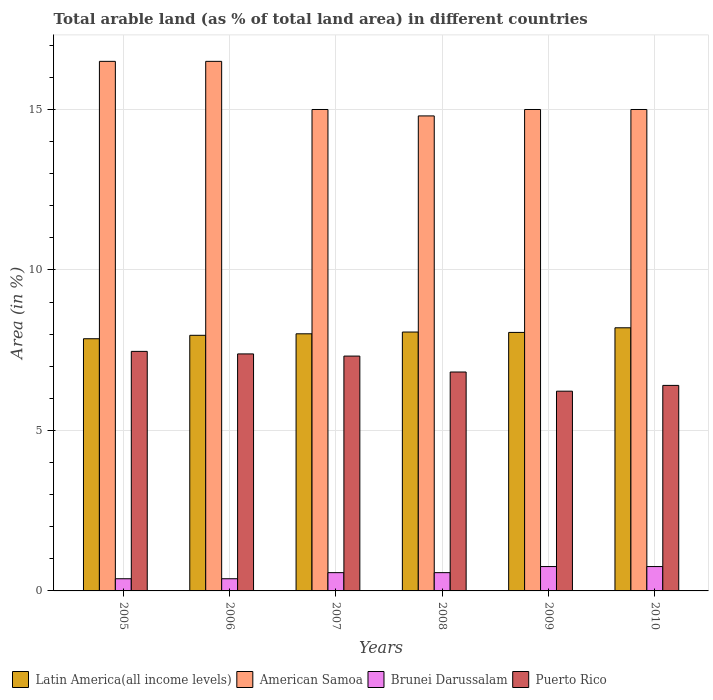How many different coloured bars are there?
Make the answer very short. 4. Are the number of bars on each tick of the X-axis equal?
Offer a terse response. Yes. What is the label of the 6th group of bars from the left?
Your response must be concise. 2010. What is the percentage of arable land in Puerto Rico in 2007?
Your answer should be very brief. 7.32. Across all years, what is the maximum percentage of arable land in Puerto Rico?
Ensure brevity in your answer.  7.46. Across all years, what is the minimum percentage of arable land in Brunei Darussalam?
Make the answer very short. 0.38. In which year was the percentage of arable land in Brunei Darussalam maximum?
Provide a short and direct response. 2009. In which year was the percentage of arable land in Puerto Rico minimum?
Give a very brief answer. 2009. What is the total percentage of arable land in Latin America(all income levels) in the graph?
Offer a very short reply. 48.15. What is the difference between the percentage of arable land in Puerto Rico in 2008 and that in 2010?
Your answer should be compact. 0.42. What is the difference between the percentage of arable land in Puerto Rico in 2010 and the percentage of arable land in Latin America(all income levels) in 2005?
Provide a short and direct response. -1.45. What is the average percentage of arable land in American Samoa per year?
Your answer should be compact. 15.47. In the year 2008, what is the difference between the percentage of arable land in Puerto Rico and percentage of arable land in Brunei Darussalam?
Your response must be concise. 6.25. What is the ratio of the percentage of arable land in Puerto Rico in 2005 to that in 2008?
Offer a terse response. 1.09. Is the difference between the percentage of arable land in Puerto Rico in 2007 and 2010 greater than the difference between the percentage of arable land in Brunei Darussalam in 2007 and 2010?
Provide a short and direct response. Yes. What is the difference between the highest and the second highest percentage of arable land in Latin America(all income levels)?
Your answer should be compact. 0.13. What is the difference between the highest and the lowest percentage of arable land in Latin America(all income levels)?
Keep it short and to the point. 0.34. In how many years, is the percentage of arable land in Brunei Darussalam greater than the average percentage of arable land in Brunei Darussalam taken over all years?
Your response must be concise. 2. Is the sum of the percentage of arable land in Puerto Rico in 2007 and 2008 greater than the maximum percentage of arable land in American Samoa across all years?
Provide a succinct answer. No. Is it the case that in every year, the sum of the percentage of arable land in Puerto Rico and percentage of arable land in American Samoa is greater than the sum of percentage of arable land in Latin America(all income levels) and percentage of arable land in Brunei Darussalam?
Ensure brevity in your answer.  Yes. What does the 4th bar from the left in 2010 represents?
Give a very brief answer. Puerto Rico. What does the 2nd bar from the right in 2009 represents?
Give a very brief answer. Brunei Darussalam. Are all the bars in the graph horizontal?
Provide a short and direct response. No. How many years are there in the graph?
Provide a succinct answer. 6. What is the difference between two consecutive major ticks on the Y-axis?
Your answer should be very brief. 5. Where does the legend appear in the graph?
Your response must be concise. Bottom left. What is the title of the graph?
Your response must be concise. Total arable land (as % of total land area) in different countries. What is the label or title of the Y-axis?
Ensure brevity in your answer.  Area (in %). What is the Area (in %) of Latin America(all income levels) in 2005?
Offer a very short reply. 7.86. What is the Area (in %) in Brunei Darussalam in 2005?
Make the answer very short. 0.38. What is the Area (in %) in Puerto Rico in 2005?
Ensure brevity in your answer.  7.46. What is the Area (in %) in Latin America(all income levels) in 2006?
Provide a succinct answer. 7.96. What is the Area (in %) of American Samoa in 2006?
Your answer should be very brief. 16.5. What is the Area (in %) in Brunei Darussalam in 2006?
Your answer should be compact. 0.38. What is the Area (in %) in Puerto Rico in 2006?
Give a very brief answer. 7.38. What is the Area (in %) of Latin America(all income levels) in 2007?
Make the answer very short. 8.01. What is the Area (in %) in American Samoa in 2007?
Provide a short and direct response. 15. What is the Area (in %) in Brunei Darussalam in 2007?
Your response must be concise. 0.57. What is the Area (in %) of Puerto Rico in 2007?
Your answer should be very brief. 7.32. What is the Area (in %) of Latin America(all income levels) in 2008?
Keep it short and to the point. 8.07. What is the Area (in %) in American Samoa in 2008?
Ensure brevity in your answer.  14.8. What is the Area (in %) in Brunei Darussalam in 2008?
Your response must be concise. 0.57. What is the Area (in %) of Puerto Rico in 2008?
Provide a short and direct response. 6.82. What is the Area (in %) in Latin America(all income levels) in 2009?
Your response must be concise. 8.05. What is the Area (in %) of American Samoa in 2009?
Your answer should be very brief. 15. What is the Area (in %) of Brunei Darussalam in 2009?
Make the answer very short. 0.76. What is the Area (in %) in Puerto Rico in 2009?
Provide a short and direct response. 6.22. What is the Area (in %) of Latin America(all income levels) in 2010?
Give a very brief answer. 8.2. What is the Area (in %) in Brunei Darussalam in 2010?
Your answer should be compact. 0.76. What is the Area (in %) in Puerto Rico in 2010?
Keep it short and to the point. 6.4. Across all years, what is the maximum Area (in %) of Latin America(all income levels)?
Offer a terse response. 8.2. Across all years, what is the maximum Area (in %) of Brunei Darussalam?
Provide a short and direct response. 0.76. Across all years, what is the maximum Area (in %) of Puerto Rico?
Provide a succinct answer. 7.46. Across all years, what is the minimum Area (in %) in Latin America(all income levels)?
Provide a short and direct response. 7.86. Across all years, what is the minimum Area (in %) of Brunei Darussalam?
Keep it short and to the point. 0.38. Across all years, what is the minimum Area (in %) of Puerto Rico?
Make the answer very short. 6.22. What is the total Area (in %) in Latin America(all income levels) in the graph?
Offer a very short reply. 48.15. What is the total Area (in %) of American Samoa in the graph?
Your answer should be very brief. 92.8. What is the total Area (in %) of Brunei Darussalam in the graph?
Provide a succinct answer. 3.42. What is the total Area (in %) of Puerto Rico in the graph?
Make the answer very short. 41.61. What is the difference between the Area (in %) in Latin America(all income levels) in 2005 and that in 2006?
Ensure brevity in your answer.  -0.11. What is the difference between the Area (in %) in Puerto Rico in 2005 and that in 2006?
Keep it short and to the point. 0.08. What is the difference between the Area (in %) of Latin America(all income levels) in 2005 and that in 2007?
Your response must be concise. -0.15. What is the difference between the Area (in %) in American Samoa in 2005 and that in 2007?
Provide a succinct answer. 1.5. What is the difference between the Area (in %) of Brunei Darussalam in 2005 and that in 2007?
Your answer should be compact. -0.19. What is the difference between the Area (in %) in Puerto Rico in 2005 and that in 2007?
Your answer should be very brief. 0.15. What is the difference between the Area (in %) of Latin America(all income levels) in 2005 and that in 2008?
Your answer should be very brief. -0.21. What is the difference between the Area (in %) of Brunei Darussalam in 2005 and that in 2008?
Offer a very short reply. -0.19. What is the difference between the Area (in %) of Puerto Rico in 2005 and that in 2008?
Your answer should be compact. 0.64. What is the difference between the Area (in %) of Latin America(all income levels) in 2005 and that in 2009?
Give a very brief answer. -0.2. What is the difference between the Area (in %) in Brunei Darussalam in 2005 and that in 2009?
Provide a succinct answer. -0.38. What is the difference between the Area (in %) in Puerto Rico in 2005 and that in 2009?
Offer a terse response. 1.24. What is the difference between the Area (in %) of Latin America(all income levels) in 2005 and that in 2010?
Provide a short and direct response. -0.34. What is the difference between the Area (in %) in American Samoa in 2005 and that in 2010?
Your answer should be compact. 1.5. What is the difference between the Area (in %) in Brunei Darussalam in 2005 and that in 2010?
Your answer should be very brief. -0.38. What is the difference between the Area (in %) in Puerto Rico in 2005 and that in 2010?
Keep it short and to the point. 1.06. What is the difference between the Area (in %) in Latin America(all income levels) in 2006 and that in 2007?
Your answer should be compact. -0.05. What is the difference between the Area (in %) of Brunei Darussalam in 2006 and that in 2007?
Make the answer very short. -0.19. What is the difference between the Area (in %) of Puerto Rico in 2006 and that in 2007?
Ensure brevity in your answer.  0.07. What is the difference between the Area (in %) of Latin America(all income levels) in 2006 and that in 2008?
Keep it short and to the point. -0.1. What is the difference between the Area (in %) in American Samoa in 2006 and that in 2008?
Provide a succinct answer. 1.7. What is the difference between the Area (in %) of Brunei Darussalam in 2006 and that in 2008?
Your answer should be compact. -0.19. What is the difference between the Area (in %) of Puerto Rico in 2006 and that in 2008?
Make the answer very short. 0.56. What is the difference between the Area (in %) of Latin America(all income levels) in 2006 and that in 2009?
Offer a very short reply. -0.09. What is the difference between the Area (in %) in American Samoa in 2006 and that in 2009?
Ensure brevity in your answer.  1.5. What is the difference between the Area (in %) of Brunei Darussalam in 2006 and that in 2009?
Your response must be concise. -0.38. What is the difference between the Area (in %) in Puerto Rico in 2006 and that in 2009?
Your answer should be compact. 1.16. What is the difference between the Area (in %) of Latin America(all income levels) in 2006 and that in 2010?
Your answer should be compact. -0.23. What is the difference between the Area (in %) of Brunei Darussalam in 2006 and that in 2010?
Provide a succinct answer. -0.38. What is the difference between the Area (in %) in Puerto Rico in 2006 and that in 2010?
Provide a succinct answer. 0.98. What is the difference between the Area (in %) in Latin America(all income levels) in 2007 and that in 2008?
Provide a succinct answer. -0.05. What is the difference between the Area (in %) of Puerto Rico in 2007 and that in 2008?
Give a very brief answer. 0.5. What is the difference between the Area (in %) in Latin America(all income levels) in 2007 and that in 2009?
Offer a terse response. -0.04. What is the difference between the Area (in %) in Brunei Darussalam in 2007 and that in 2009?
Keep it short and to the point. -0.19. What is the difference between the Area (in %) of Puerto Rico in 2007 and that in 2009?
Keep it short and to the point. 1.09. What is the difference between the Area (in %) in Latin America(all income levels) in 2007 and that in 2010?
Make the answer very short. -0.19. What is the difference between the Area (in %) of Brunei Darussalam in 2007 and that in 2010?
Your response must be concise. -0.19. What is the difference between the Area (in %) of Puerto Rico in 2007 and that in 2010?
Make the answer very short. 0.91. What is the difference between the Area (in %) in Latin America(all income levels) in 2008 and that in 2009?
Give a very brief answer. 0.01. What is the difference between the Area (in %) in American Samoa in 2008 and that in 2009?
Provide a short and direct response. -0.2. What is the difference between the Area (in %) of Brunei Darussalam in 2008 and that in 2009?
Provide a short and direct response. -0.19. What is the difference between the Area (in %) in Puerto Rico in 2008 and that in 2009?
Your answer should be compact. 0.6. What is the difference between the Area (in %) of Latin America(all income levels) in 2008 and that in 2010?
Provide a succinct answer. -0.13. What is the difference between the Area (in %) in American Samoa in 2008 and that in 2010?
Make the answer very short. -0.2. What is the difference between the Area (in %) of Brunei Darussalam in 2008 and that in 2010?
Your response must be concise. -0.19. What is the difference between the Area (in %) in Puerto Rico in 2008 and that in 2010?
Make the answer very short. 0.42. What is the difference between the Area (in %) in Latin America(all income levels) in 2009 and that in 2010?
Your answer should be very brief. -0.14. What is the difference between the Area (in %) of American Samoa in 2009 and that in 2010?
Give a very brief answer. 0. What is the difference between the Area (in %) of Brunei Darussalam in 2009 and that in 2010?
Your answer should be compact. 0. What is the difference between the Area (in %) of Puerto Rico in 2009 and that in 2010?
Provide a short and direct response. -0.18. What is the difference between the Area (in %) in Latin America(all income levels) in 2005 and the Area (in %) in American Samoa in 2006?
Ensure brevity in your answer.  -8.64. What is the difference between the Area (in %) in Latin America(all income levels) in 2005 and the Area (in %) in Brunei Darussalam in 2006?
Offer a terse response. 7.48. What is the difference between the Area (in %) of Latin America(all income levels) in 2005 and the Area (in %) of Puerto Rico in 2006?
Keep it short and to the point. 0.47. What is the difference between the Area (in %) in American Samoa in 2005 and the Area (in %) in Brunei Darussalam in 2006?
Make the answer very short. 16.12. What is the difference between the Area (in %) of American Samoa in 2005 and the Area (in %) of Puerto Rico in 2006?
Provide a succinct answer. 9.12. What is the difference between the Area (in %) in Brunei Darussalam in 2005 and the Area (in %) in Puerto Rico in 2006?
Keep it short and to the point. -7. What is the difference between the Area (in %) of Latin America(all income levels) in 2005 and the Area (in %) of American Samoa in 2007?
Keep it short and to the point. -7.14. What is the difference between the Area (in %) of Latin America(all income levels) in 2005 and the Area (in %) of Brunei Darussalam in 2007?
Give a very brief answer. 7.29. What is the difference between the Area (in %) in Latin America(all income levels) in 2005 and the Area (in %) in Puerto Rico in 2007?
Your response must be concise. 0.54. What is the difference between the Area (in %) in American Samoa in 2005 and the Area (in %) in Brunei Darussalam in 2007?
Make the answer very short. 15.93. What is the difference between the Area (in %) of American Samoa in 2005 and the Area (in %) of Puerto Rico in 2007?
Your answer should be compact. 9.18. What is the difference between the Area (in %) in Brunei Darussalam in 2005 and the Area (in %) in Puerto Rico in 2007?
Offer a very short reply. -6.94. What is the difference between the Area (in %) in Latin America(all income levels) in 2005 and the Area (in %) in American Samoa in 2008?
Offer a terse response. -6.94. What is the difference between the Area (in %) in Latin America(all income levels) in 2005 and the Area (in %) in Brunei Darussalam in 2008?
Provide a short and direct response. 7.29. What is the difference between the Area (in %) of Latin America(all income levels) in 2005 and the Area (in %) of Puerto Rico in 2008?
Provide a succinct answer. 1.04. What is the difference between the Area (in %) of American Samoa in 2005 and the Area (in %) of Brunei Darussalam in 2008?
Keep it short and to the point. 15.93. What is the difference between the Area (in %) of American Samoa in 2005 and the Area (in %) of Puerto Rico in 2008?
Give a very brief answer. 9.68. What is the difference between the Area (in %) in Brunei Darussalam in 2005 and the Area (in %) in Puerto Rico in 2008?
Your answer should be compact. -6.44. What is the difference between the Area (in %) in Latin America(all income levels) in 2005 and the Area (in %) in American Samoa in 2009?
Your answer should be very brief. -7.14. What is the difference between the Area (in %) of Latin America(all income levels) in 2005 and the Area (in %) of Brunei Darussalam in 2009?
Your answer should be compact. 7.1. What is the difference between the Area (in %) in Latin America(all income levels) in 2005 and the Area (in %) in Puerto Rico in 2009?
Give a very brief answer. 1.63. What is the difference between the Area (in %) in American Samoa in 2005 and the Area (in %) in Brunei Darussalam in 2009?
Your response must be concise. 15.74. What is the difference between the Area (in %) in American Samoa in 2005 and the Area (in %) in Puerto Rico in 2009?
Offer a terse response. 10.28. What is the difference between the Area (in %) of Brunei Darussalam in 2005 and the Area (in %) of Puerto Rico in 2009?
Keep it short and to the point. -5.84. What is the difference between the Area (in %) of Latin America(all income levels) in 2005 and the Area (in %) of American Samoa in 2010?
Provide a succinct answer. -7.14. What is the difference between the Area (in %) of Latin America(all income levels) in 2005 and the Area (in %) of Brunei Darussalam in 2010?
Ensure brevity in your answer.  7.1. What is the difference between the Area (in %) in Latin America(all income levels) in 2005 and the Area (in %) in Puerto Rico in 2010?
Offer a very short reply. 1.45. What is the difference between the Area (in %) of American Samoa in 2005 and the Area (in %) of Brunei Darussalam in 2010?
Your response must be concise. 15.74. What is the difference between the Area (in %) in American Samoa in 2005 and the Area (in %) in Puerto Rico in 2010?
Offer a terse response. 10.1. What is the difference between the Area (in %) of Brunei Darussalam in 2005 and the Area (in %) of Puerto Rico in 2010?
Provide a succinct answer. -6.02. What is the difference between the Area (in %) in Latin America(all income levels) in 2006 and the Area (in %) in American Samoa in 2007?
Your response must be concise. -7.04. What is the difference between the Area (in %) in Latin America(all income levels) in 2006 and the Area (in %) in Brunei Darussalam in 2007?
Keep it short and to the point. 7.39. What is the difference between the Area (in %) of Latin America(all income levels) in 2006 and the Area (in %) of Puerto Rico in 2007?
Give a very brief answer. 0.65. What is the difference between the Area (in %) of American Samoa in 2006 and the Area (in %) of Brunei Darussalam in 2007?
Provide a short and direct response. 15.93. What is the difference between the Area (in %) of American Samoa in 2006 and the Area (in %) of Puerto Rico in 2007?
Your answer should be compact. 9.18. What is the difference between the Area (in %) of Brunei Darussalam in 2006 and the Area (in %) of Puerto Rico in 2007?
Keep it short and to the point. -6.94. What is the difference between the Area (in %) of Latin America(all income levels) in 2006 and the Area (in %) of American Samoa in 2008?
Offer a very short reply. -6.84. What is the difference between the Area (in %) of Latin America(all income levels) in 2006 and the Area (in %) of Brunei Darussalam in 2008?
Ensure brevity in your answer.  7.39. What is the difference between the Area (in %) of Latin America(all income levels) in 2006 and the Area (in %) of Puerto Rico in 2008?
Offer a very short reply. 1.14. What is the difference between the Area (in %) of American Samoa in 2006 and the Area (in %) of Brunei Darussalam in 2008?
Offer a terse response. 15.93. What is the difference between the Area (in %) of American Samoa in 2006 and the Area (in %) of Puerto Rico in 2008?
Offer a terse response. 9.68. What is the difference between the Area (in %) in Brunei Darussalam in 2006 and the Area (in %) in Puerto Rico in 2008?
Ensure brevity in your answer.  -6.44. What is the difference between the Area (in %) of Latin America(all income levels) in 2006 and the Area (in %) of American Samoa in 2009?
Make the answer very short. -7.04. What is the difference between the Area (in %) in Latin America(all income levels) in 2006 and the Area (in %) in Brunei Darussalam in 2009?
Ensure brevity in your answer.  7.21. What is the difference between the Area (in %) of Latin America(all income levels) in 2006 and the Area (in %) of Puerto Rico in 2009?
Provide a succinct answer. 1.74. What is the difference between the Area (in %) in American Samoa in 2006 and the Area (in %) in Brunei Darussalam in 2009?
Provide a succinct answer. 15.74. What is the difference between the Area (in %) in American Samoa in 2006 and the Area (in %) in Puerto Rico in 2009?
Your response must be concise. 10.28. What is the difference between the Area (in %) of Brunei Darussalam in 2006 and the Area (in %) of Puerto Rico in 2009?
Make the answer very short. -5.84. What is the difference between the Area (in %) of Latin America(all income levels) in 2006 and the Area (in %) of American Samoa in 2010?
Your answer should be very brief. -7.04. What is the difference between the Area (in %) in Latin America(all income levels) in 2006 and the Area (in %) in Brunei Darussalam in 2010?
Provide a succinct answer. 7.21. What is the difference between the Area (in %) in Latin America(all income levels) in 2006 and the Area (in %) in Puerto Rico in 2010?
Offer a very short reply. 1.56. What is the difference between the Area (in %) in American Samoa in 2006 and the Area (in %) in Brunei Darussalam in 2010?
Your response must be concise. 15.74. What is the difference between the Area (in %) of American Samoa in 2006 and the Area (in %) of Puerto Rico in 2010?
Make the answer very short. 10.1. What is the difference between the Area (in %) in Brunei Darussalam in 2006 and the Area (in %) in Puerto Rico in 2010?
Provide a short and direct response. -6.02. What is the difference between the Area (in %) of Latin America(all income levels) in 2007 and the Area (in %) of American Samoa in 2008?
Provide a succinct answer. -6.79. What is the difference between the Area (in %) of Latin America(all income levels) in 2007 and the Area (in %) of Brunei Darussalam in 2008?
Make the answer very short. 7.44. What is the difference between the Area (in %) of Latin America(all income levels) in 2007 and the Area (in %) of Puerto Rico in 2008?
Ensure brevity in your answer.  1.19. What is the difference between the Area (in %) in American Samoa in 2007 and the Area (in %) in Brunei Darussalam in 2008?
Give a very brief answer. 14.43. What is the difference between the Area (in %) in American Samoa in 2007 and the Area (in %) in Puerto Rico in 2008?
Provide a short and direct response. 8.18. What is the difference between the Area (in %) in Brunei Darussalam in 2007 and the Area (in %) in Puerto Rico in 2008?
Give a very brief answer. -6.25. What is the difference between the Area (in %) in Latin America(all income levels) in 2007 and the Area (in %) in American Samoa in 2009?
Provide a succinct answer. -6.99. What is the difference between the Area (in %) in Latin America(all income levels) in 2007 and the Area (in %) in Brunei Darussalam in 2009?
Provide a short and direct response. 7.25. What is the difference between the Area (in %) of Latin America(all income levels) in 2007 and the Area (in %) of Puerto Rico in 2009?
Make the answer very short. 1.79. What is the difference between the Area (in %) of American Samoa in 2007 and the Area (in %) of Brunei Darussalam in 2009?
Your answer should be very brief. 14.24. What is the difference between the Area (in %) in American Samoa in 2007 and the Area (in %) in Puerto Rico in 2009?
Provide a short and direct response. 8.78. What is the difference between the Area (in %) of Brunei Darussalam in 2007 and the Area (in %) of Puerto Rico in 2009?
Offer a very short reply. -5.65. What is the difference between the Area (in %) of Latin America(all income levels) in 2007 and the Area (in %) of American Samoa in 2010?
Your response must be concise. -6.99. What is the difference between the Area (in %) of Latin America(all income levels) in 2007 and the Area (in %) of Brunei Darussalam in 2010?
Your answer should be compact. 7.25. What is the difference between the Area (in %) of Latin America(all income levels) in 2007 and the Area (in %) of Puerto Rico in 2010?
Make the answer very short. 1.61. What is the difference between the Area (in %) of American Samoa in 2007 and the Area (in %) of Brunei Darussalam in 2010?
Your answer should be very brief. 14.24. What is the difference between the Area (in %) in American Samoa in 2007 and the Area (in %) in Puerto Rico in 2010?
Offer a terse response. 8.6. What is the difference between the Area (in %) in Brunei Darussalam in 2007 and the Area (in %) in Puerto Rico in 2010?
Provide a succinct answer. -5.83. What is the difference between the Area (in %) of Latin America(all income levels) in 2008 and the Area (in %) of American Samoa in 2009?
Make the answer very short. -6.93. What is the difference between the Area (in %) in Latin America(all income levels) in 2008 and the Area (in %) in Brunei Darussalam in 2009?
Make the answer very short. 7.31. What is the difference between the Area (in %) of Latin America(all income levels) in 2008 and the Area (in %) of Puerto Rico in 2009?
Make the answer very short. 1.84. What is the difference between the Area (in %) of American Samoa in 2008 and the Area (in %) of Brunei Darussalam in 2009?
Your answer should be very brief. 14.04. What is the difference between the Area (in %) in American Samoa in 2008 and the Area (in %) in Puerto Rico in 2009?
Offer a terse response. 8.58. What is the difference between the Area (in %) in Brunei Darussalam in 2008 and the Area (in %) in Puerto Rico in 2009?
Make the answer very short. -5.65. What is the difference between the Area (in %) in Latin America(all income levels) in 2008 and the Area (in %) in American Samoa in 2010?
Give a very brief answer. -6.93. What is the difference between the Area (in %) in Latin America(all income levels) in 2008 and the Area (in %) in Brunei Darussalam in 2010?
Provide a succinct answer. 7.31. What is the difference between the Area (in %) of Latin America(all income levels) in 2008 and the Area (in %) of Puerto Rico in 2010?
Offer a terse response. 1.66. What is the difference between the Area (in %) of American Samoa in 2008 and the Area (in %) of Brunei Darussalam in 2010?
Your answer should be compact. 14.04. What is the difference between the Area (in %) in American Samoa in 2008 and the Area (in %) in Puerto Rico in 2010?
Your response must be concise. 8.4. What is the difference between the Area (in %) of Brunei Darussalam in 2008 and the Area (in %) of Puerto Rico in 2010?
Provide a succinct answer. -5.83. What is the difference between the Area (in %) in Latin America(all income levels) in 2009 and the Area (in %) in American Samoa in 2010?
Keep it short and to the point. -6.95. What is the difference between the Area (in %) of Latin America(all income levels) in 2009 and the Area (in %) of Brunei Darussalam in 2010?
Make the answer very short. 7.3. What is the difference between the Area (in %) in Latin America(all income levels) in 2009 and the Area (in %) in Puerto Rico in 2010?
Keep it short and to the point. 1.65. What is the difference between the Area (in %) of American Samoa in 2009 and the Area (in %) of Brunei Darussalam in 2010?
Offer a very short reply. 14.24. What is the difference between the Area (in %) of American Samoa in 2009 and the Area (in %) of Puerto Rico in 2010?
Offer a terse response. 8.6. What is the difference between the Area (in %) in Brunei Darussalam in 2009 and the Area (in %) in Puerto Rico in 2010?
Give a very brief answer. -5.64. What is the average Area (in %) of Latin America(all income levels) per year?
Give a very brief answer. 8.03. What is the average Area (in %) of American Samoa per year?
Make the answer very short. 15.47. What is the average Area (in %) in Brunei Darussalam per year?
Keep it short and to the point. 0.57. What is the average Area (in %) of Puerto Rico per year?
Offer a terse response. 6.94. In the year 2005, what is the difference between the Area (in %) in Latin America(all income levels) and Area (in %) in American Samoa?
Give a very brief answer. -8.64. In the year 2005, what is the difference between the Area (in %) in Latin America(all income levels) and Area (in %) in Brunei Darussalam?
Make the answer very short. 7.48. In the year 2005, what is the difference between the Area (in %) of Latin America(all income levels) and Area (in %) of Puerto Rico?
Offer a terse response. 0.39. In the year 2005, what is the difference between the Area (in %) of American Samoa and Area (in %) of Brunei Darussalam?
Your response must be concise. 16.12. In the year 2005, what is the difference between the Area (in %) of American Samoa and Area (in %) of Puerto Rico?
Give a very brief answer. 9.04. In the year 2005, what is the difference between the Area (in %) in Brunei Darussalam and Area (in %) in Puerto Rico?
Provide a short and direct response. -7.08. In the year 2006, what is the difference between the Area (in %) in Latin America(all income levels) and Area (in %) in American Samoa?
Your answer should be very brief. -8.54. In the year 2006, what is the difference between the Area (in %) in Latin America(all income levels) and Area (in %) in Brunei Darussalam?
Make the answer very short. 7.58. In the year 2006, what is the difference between the Area (in %) in Latin America(all income levels) and Area (in %) in Puerto Rico?
Give a very brief answer. 0.58. In the year 2006, what is the difference between the Area (in %) in American Samoa and Area (in %) in Brunei Darussalam?
Keep it short and to the point. 16.12. In the year 2006, what is the difference between the Area (in %) in American Samoa and Area (in %) in Puerto Rico?
Ensure brevity in your answer.  9.12. In the year 2006, what is the difference between the Area (in %) in Brunei Darussalam and Area (in %) in Puerto Rico?
Keep it short and to the point. -7. In the year 2007, what is the difference between the Area (in %) of Latin America(all income levels) and Area (in %) of American Samoa?
Your response must be concise. -6.99. In the year 2007, what is the difference between the Area (in %) in Latin America(all income levels) and Area (in %) in Brunei Darussalam?
Ensure brevity in your answer.  7.44. In the year 2007, what is the difference between the Area (in %) in Latin America(all income levels) and Area (in %) in Puerto Rico?
Ensure brevity in your answer.  0.69. In the year 2007, what is the difference between the Area (in %) of American Samoa and Area (in %) of Brunei Darussalam?
Your answer should be very brief. 14.43. In the year 2007, what is the difference between the Area (in %) of American Samoa and Area (in %) of Puerto Rico?
Provide a succinct answer. 7.68. In the year 2007, what is the difference between the Area (in %) of Brunei Darussalam and Area (in %) of Puerto Rico?
Your answer should be compact. -6.75. In the year 2008, what is the difference between the Area (in %) in Latin America(all income levels) and Area (in %) in American Samoa?
Provide a succinct answer. -6.73. In the year 2008, what is the difference between the Area (in %) in Latin America(all income levels) and Area (in %) in Brunei Darussalam?
Make the answer very short. 7.5. In the year 2008, what is the difference between the Area (in %) in Latin America(all income levels) and Area (in %) in Puerto Rico?
Ensure brevity in your answer.  1.25. In the year 2008, what is the difference between the Area (in %) of American Samoa and Area (in %) of Brunei Darussalam?
Your answer should be very brief. 14.23. In the year 2008, what is the difference between the Area (in %) in American Samoa and Area (in %) in Puerto Rico?
Provide a succinct answer. 7.98. In the year 2008, what is the difference between the Area (in %) of Brunei Darussalam and Area (in %) of Puerto Rico?
Keep it short and to the point. -6.25. In the year 2009, what is the difference between the Area (in %) of Latin America(all income levels) and Area (in %) of American Samoa?
Make the answer very short. -6.95. In the year 2009, what is the difference between the Area (in %) of Latin America(all income levels) and Area (in %) of Brunei Darussalam?
Provide a short and direct response. 7.3. In the year 2009, what is the difference between the Area (in %) in Latin America(all income levels) and Area (in %) in Puerto Rico?
Provide a short and direct response. 1.83. In the year 2009, what is the difference between the Area (in %) of American Samoa and Area (in %) of Brunei Darussalam?
Your answer should be very brief. 14.24. In the year 2009, what is the difference between the Area (in %) of American Samoa and Area (in %) of Puerto Rico?
Provide a succinct answer. 8.78. In the year 2009, what is the difference between the Area (in %) in Brunei Darussalam and Area (in %) in Puerto Rico?
Provide a short and direct response. -5.46. In the year 2010, what is the difference between the Area (in %) of Latin America(all income levels) and Area (in %) of American Samoa?
Your answer should be compact. -6.8. In the year 2010, what is the difference between the Area (in %) of Latin America(all income levels) and Area (in %) of Brunei Darussalam?
Your response must be concise. 7.44. In the year 2010, what is the difference between the Area (in %) in Latin America(all income levels) and Area (in %) in Puerto Rico?
Your response must be concise. 1.79. In the year 2010, what is the difference between the Area (in %) in American Samoa and Area (in %) in Brunei Darussalam?
Provide a short and direct response. 14.24. In the year 2010, what is the difference between the Area (in %) of American Samoa and Area (in %) of Puerto Rico?
Make the answer very short. 8.6. In the year 2010, what is the difference between the Area (in %) of Brunei Darussalam and Area (in %) of Puerto Rico?
Offer a very short reply. -5.64. What is the ratio of the Area (in %) in Latin America(all income levels) in 2005 to that in 2006?
Offer a terse response. 0.99. What is the ratio of the Area (in %) of American Samoa in 2005 to that in 2006?
Offer a terse response. 1. What is the ratio of the Area (in %) of Brunei Darussalam in 2005 to that in 2006?
Make the answer very short. 1. What is the ratio of the Area (in %) of Puerto Rico in 2005 to that in 2006?
Give a very brief answer. 1.01. What is the ratio of the Area (in %) in Latin America(all income levels) in 2005 to that in 2007?
Provide a short and direct response. 0.98. What is the ratio of the Area (in %) in Latin America(all income levels) in 2005 to that in 2008?
Your answer should be compact. 0.97. What is the ratio of the Area (in %) in American Samoa in 2005 to that in 2008?
Give a very brief answer. 1.11. What is the ratio of the Area (in %) of Brunei Darussalam in 2005 to that in 2008?
Give a very brief answer. 0.67. What is the ratio of the Area (in %) of Puerto Rico in 2005 to that in 2008?
Provide a short and direct response. 1.09. What is the ratio of the Area (in %) in Latin America(all income levels) in 2005 to that in 2009?
Your answer should be compact. 0.98. What is the ratio of the Area (in %) of Brunei Darussalam in 2005 to that in 2009?
Ensure brevity in your answer.  0.5. What is the ratio of the Area (in %) of Puerto Rico in 2005 to that in 2009?
Offer a very short reply. 1.2. What is the ratio of the Area (in %) in Latin America(all income levels) in 2005 to that in 2010?
Make the answer very short. 0.96. What is the ratio of the Area (in %) in Puerto Rico in 2005 to that in 2010?
Your answer should be compact. 1.17. What is the ratio of the Area (in %) of Brunei Darussalam in 2006 to that in 2007?
Keep it short and to the point. 0.67. What is the ratio of the Area (in %) in Puerto Rico in 2006 to that in 2007?
Provide a succinct answer. 1.01. What is the ratio of the Area (in %) in Latin America(all income levels) in 2006 to that in 2008?
Your answer should be very brief. 0.99. What is the ratio of the Area (in %) in American Samoa in 2006 to that in 2008?
Provide a short and direct response. 1.11. What is the ratio of the Area (in %) in Brunei Darussalam in 2006 to that in 2008?
Make the answer very short. 0.67. What is the ratio of the Area (in %) of Puerto Rico in 2006 to that in 2008?
Give a very brief answer. 1.08. What is the ratio of the Area (in %) of Puerto Rico in 2006 to that in 2009?
Offer a terse response. 1.19. What is the ratio of the Area (in %) of Latin America(all income levels) in 2006 to that in 2010?
Provide a succinct answer. 0.97. What is the ratio of the Area (in %) of American Samoa in 2006 to that in 2010?
Provide a short and direct response. 1.1. What is the ratio of the Area (in %) of Puerto Rico in 2006 to that in 2010?
Make the answer very short. 1.15. What is the ratio of the Area (in %) of American Samoa in 2007 to that in 2008?
Your response must be concise. 1.01. What is the ratio of the Area (in %) in Brunei Darussalam in 2007 to that in 2008?
Offer a very short reply. 1. What is the ratio of the Area (in %) of Puerto Rico in 2007 to that in 2008?
Provide a short and direct response. 1.07. What is the ratio of the Area (in %) of Latin America(all income levels) in 2007 to that in 2009?
Provide a succinct answer. 0.99. What is the ratio of the Area (in %) of American Samoa in 2007 to that in 2009?
Your response must be concise. 1. What is the ratio of the Area (in %) in Puerto Rico in 2007 to that in 2009?
Your response must be concise. 1.18. What is the ratio of the Area (in %) in Latin America(all income levels) in 2007 to that in 2010?
Ensure brevity in your answer.  0.98. What is the ratio of the Area (in %) in American Samoa in 2007 to that in 2010?
Keep it short and to the point. 1. What is the ratio of the Area (in %) of Puerto Rico in 2007 to that in 2010?
Offer a very short reply. 1.14. What is the ratio of the Area (in %) of American Samoa in 2008 to that in 2009?
Keep it short and to the point. 0.99. What is the ratio of the Area (in %) in Puerto Rico in 2008 to that in 2009?
Keep it short and to the point. 1.1. What is the ratio of the Area (in %) of Latin America(all income levels) in 2008 to that in 2010?
Your answer should be compact. 0.98. What is the ratio of the Area (in %) in American Samoa in 2008 to that in 2010?
Make the answer very short. 0.99. What is the ratio of the Area (in %) in Puerto Rico in 2008 to that in 2010?
Provide a succinct answer. 1.07. What is the ratio of the Area (in %) in Latin America(all income levels) in 2009 to that in 2010?
Ensure brevity in your answer.  0.98. What is the ratio of the Area (in %) in Brunei Darussalam in 2009 to that in 2010?
Offer a terse response. 1. What is the ratio of the Area (in %) in Puerto Rico in 2009 to that in 2010?
Provide a short and direct response. 0.97. What is the difference between the highest and the second highest Area (in %) of Latin America(all income levels)?
Make the answer very short. 0.13. What is the difference between the highest and the second highest Area (in %) of Puerto Rico?
Offer a terse response. 0.08. What is the difference between the highest and the lowest Area (in %) in Latin America(all income levels)?
Your answer should be compact. 0.34. What is the difference between the highest and the lowest Area (in %) of Brunei Darussalam?
Keep it short and to the point. 0.38. What is the difference between the highest and the lowest Area (in %) of Puerto Rico?
Your response must be concise. 1.24. 